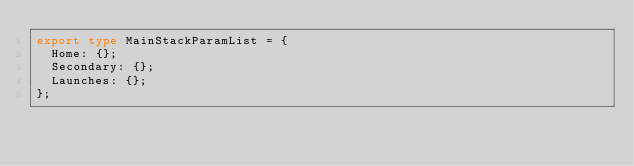<code> <loc_0><loc_0><loc_500><loc_500><_TypeScript_>export type MainStackParamList = {
  Home: {};
  Secondary: {};
  Launches: {};
};
</code> 